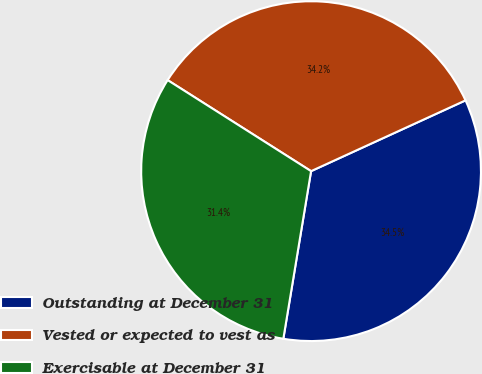Convert chart. <chart><loc_0><loc_0><loc_500><loc_500><pie_chart><fcel>Outstanding at December 31<fcel>Vested or expected to vest as<fcel>Exercisable at December 31<nl><fcel>34.45%<fcel>34.16%<fcel>31.39%<nl></chart> 